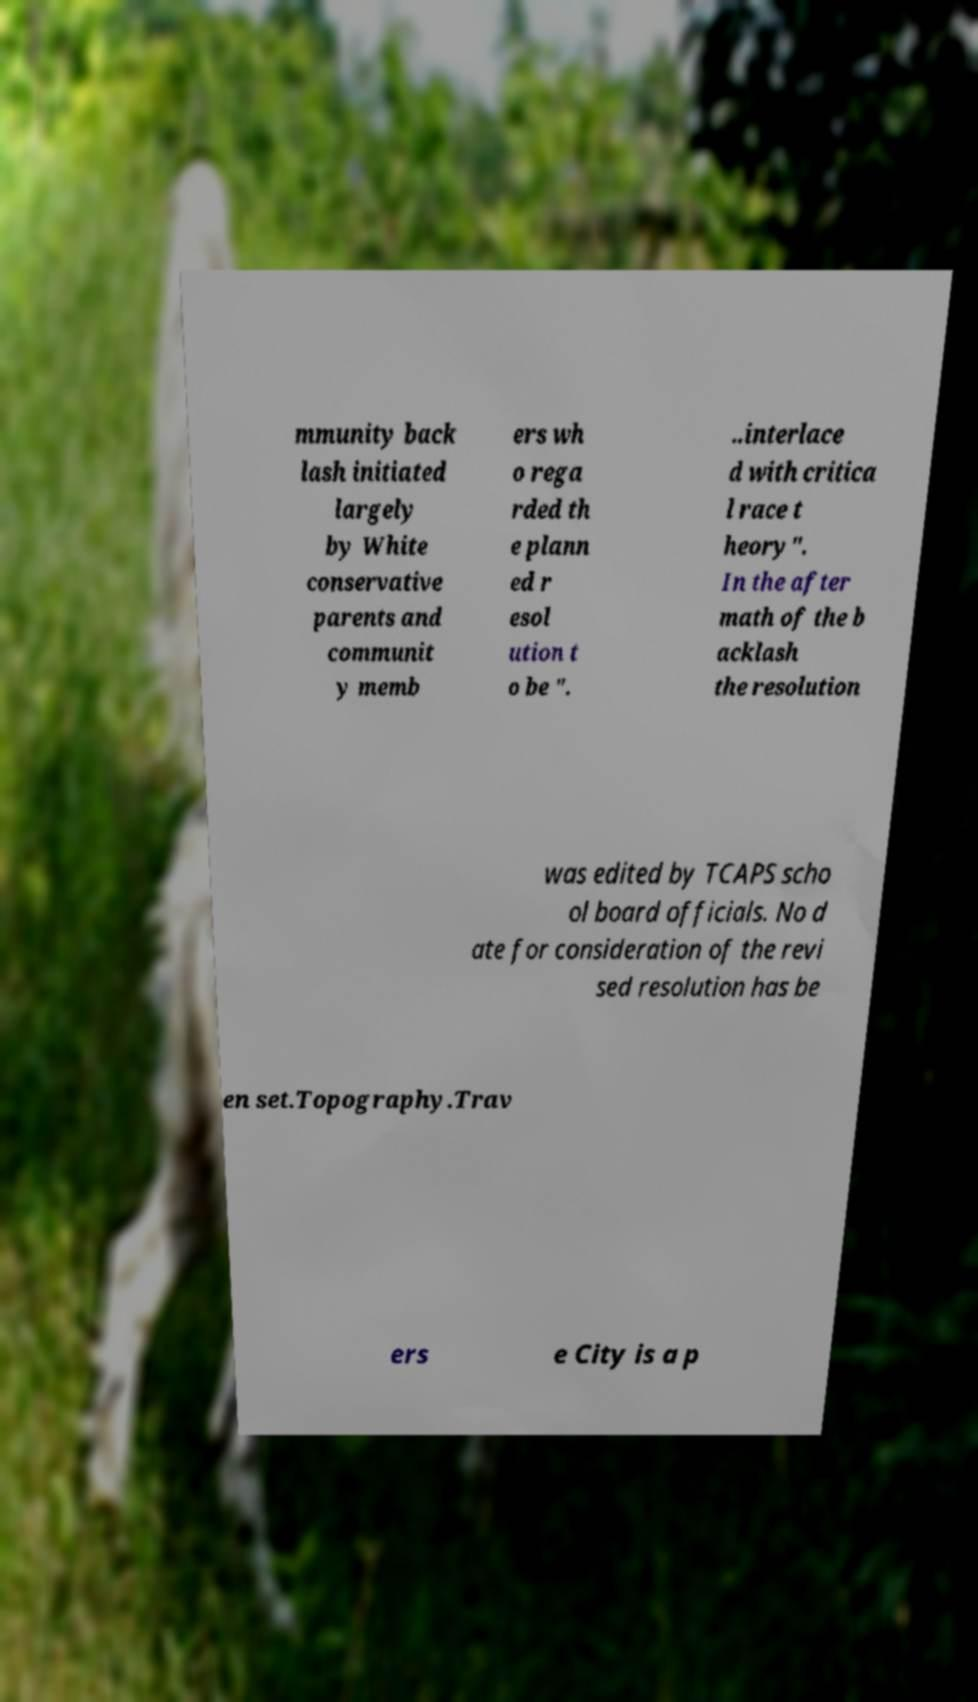Can you accurately transcribe the text from the provided image for me? mmunity back lash initiated largely by White conservative parents and communit y memb ers wh o rega rded th e plann ed r esol ution t o be ". ..interlace d with critica l race t heory". In the after math of the b acklash the resolution was edited by TCAPS scho ol board officials. No d ate for consideration of the revi sed resolution has be en set.Topography.Trav ers e City is a p 